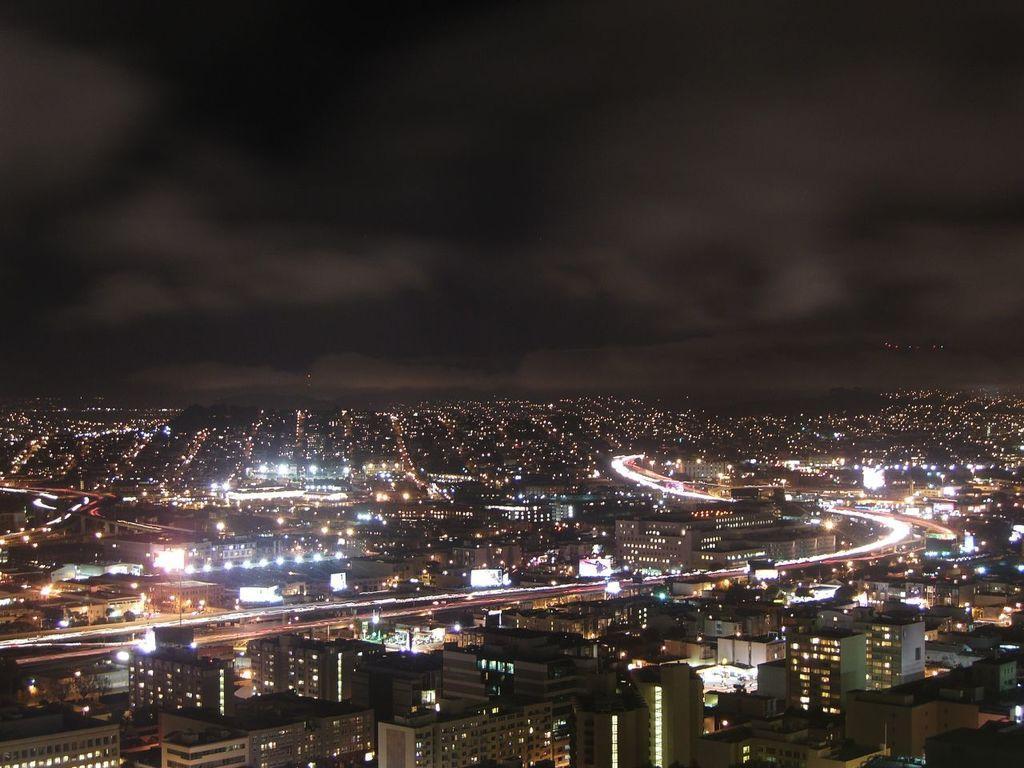Describe this image in one or two sentences. This is an image clicked in the dark. At the bottom of this image there are many buildings and lights. At the top I can see the sky. 